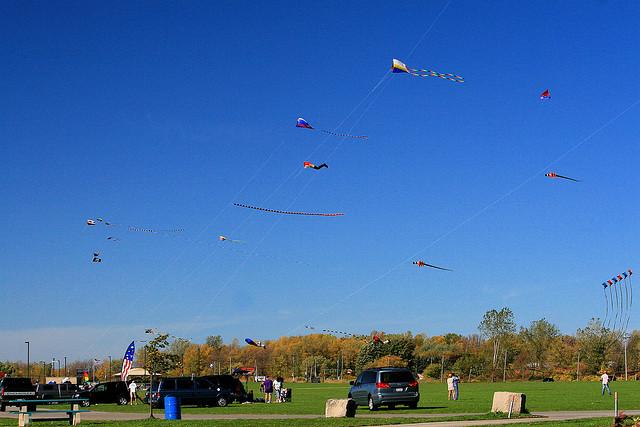Are these kites in danger of becoming entangled with each other?
Concise answer only. Yes. What kind of weather is here?
Write a very short answer. Sunny. Are any of the vehicles in motion?
Give a very brief answer. Yes. What is keeping the kites in the air?
Give a very brief answer. Wind. Is this a city scene?
Short answer required. No. Are there clouds in the sky?
Keep it brief. No. 